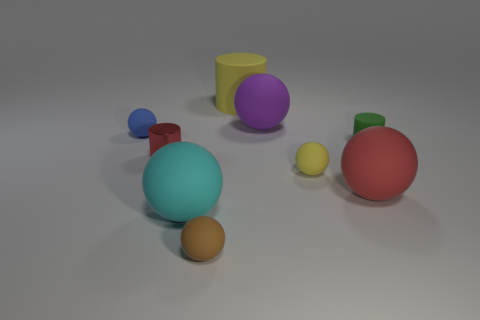There is a cyan rubber object that is the same size as the red ball; what shape is it?
Provide a short and direct response. Sphere. There is a big matte thing that is the same shape as the red metallic thing; what color is it?
Provide a succinct answer. Yellow. What number of objects are either yellow matte balls or small cylinders?
Offer a terse response. 3. There is a small rubber object that is on the left side of the small brown thing; is its shape the same as the small yellow object in front of the big matte cylinder?
Offer a very short reply. Yes. There is a tiny green thing behind the big red rubber sphere; what shape is it?
Offer a terse response. Cylinder. Are there an equal number of brown rubber objects left of the cyan thing and large matte spheres to the left of the brown ball?
Offer a very short reply. No. What number of things are either tiny cyan spheres or cylinders behind the small blue rubber ball?
Keep it short and to the point. 1. There is a tiny matte object that is behind the metallic cylinder and to the right of the large yellow thing; what is its shape?
Your response must be concise. Cylinder. The small cylinder that is on the left side of the matte cylinder that is right of the small yellow matte sphere is made of what material?
Ensure brevity in your answer.  Metal. Is the material of the red thing that is right of the tiny yellow object the same as the brown thing?
Your answer should be very brief. Yes. 